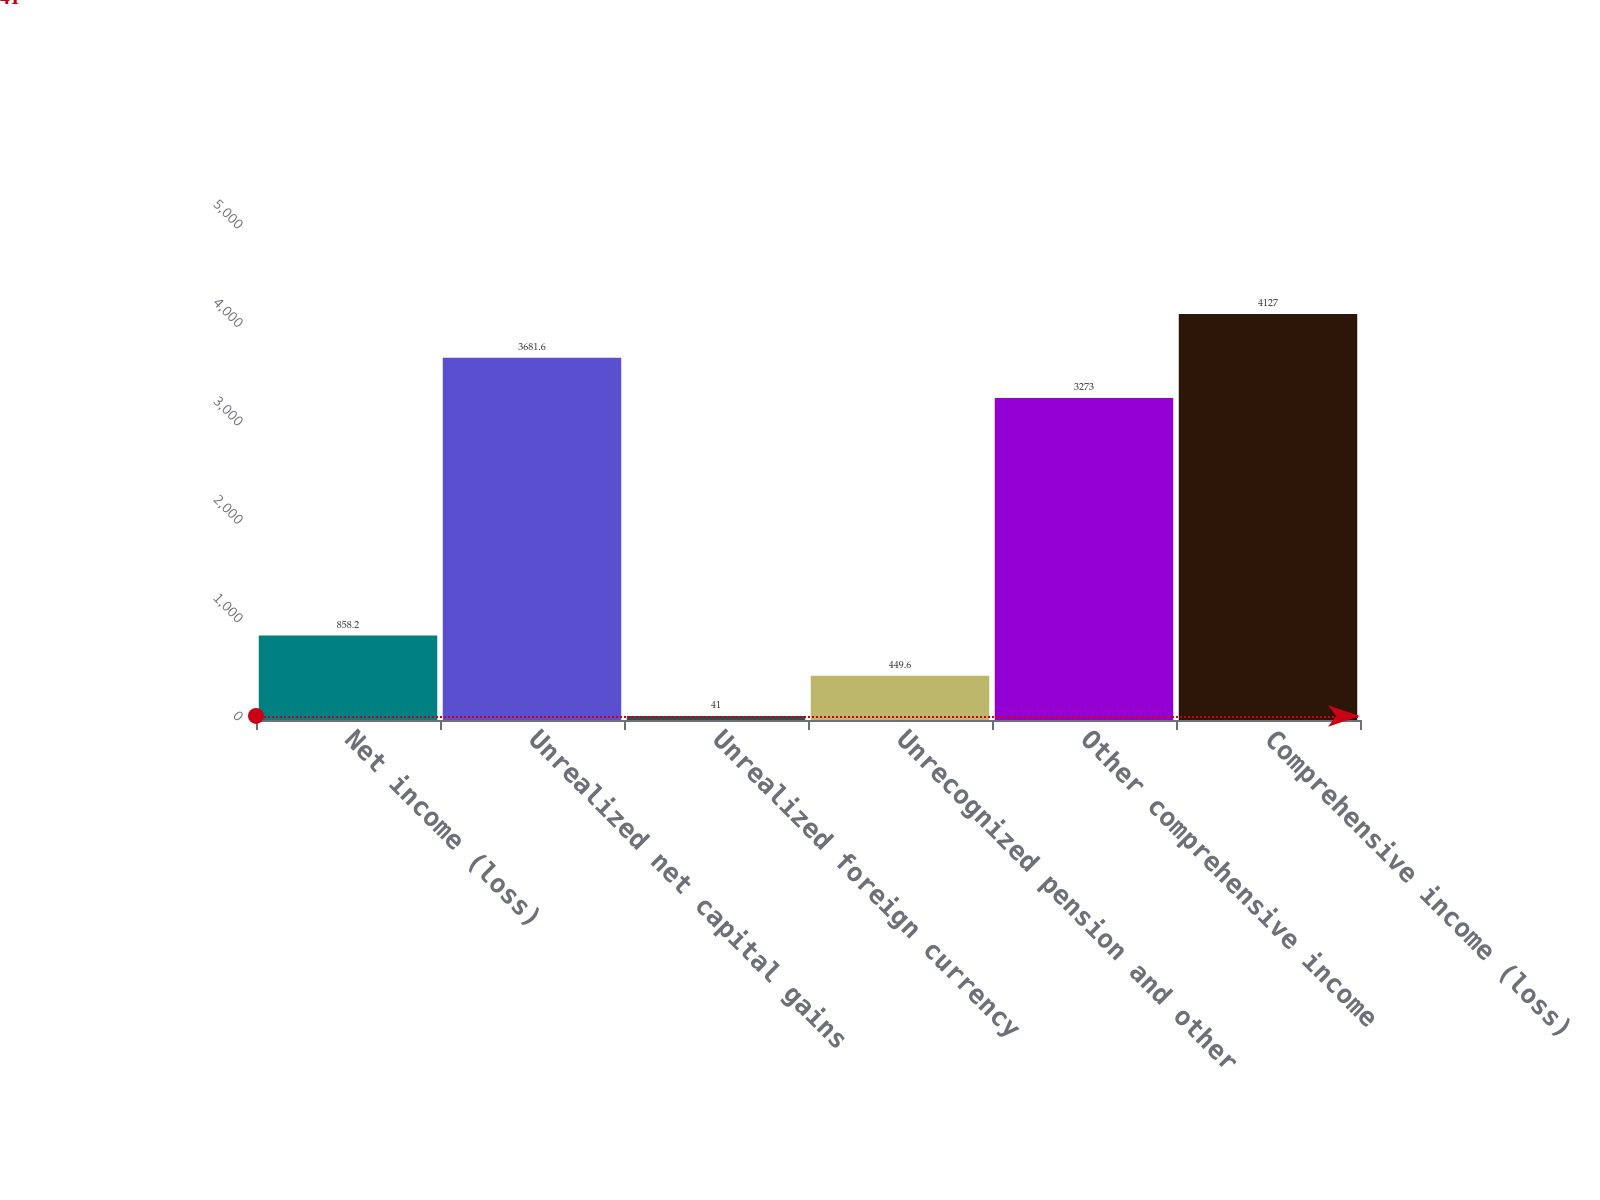Convert chart. <chart><loc_0><loc_0><loc_500><loc_500><bar_chart><fcel>Net income (loss)<fcel>Unrealized net capital gains<fcel>Unrealized foreign currency<fcel>Unrecognized pension and other<fcel>Other comprehensive income<fcel>Comprehensive income (loss)<nl><fcel>858.2<fcel>3681.6<fcel>41<fcel>449.6<fcel>3273<fcel>4127<nl></chart> 